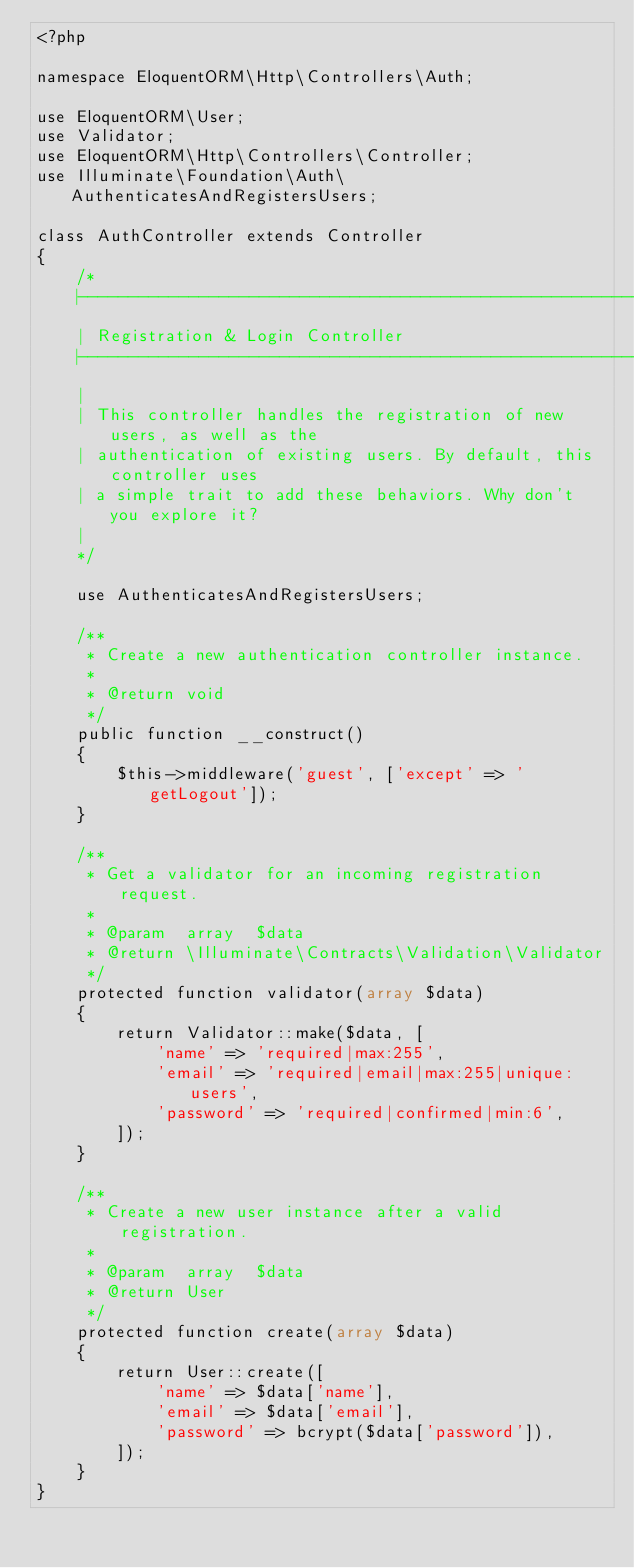<code> <loc_0><loc_0><loc_500><loc_500><_PHP_><?php

namespace EloquentORM\Http\Controllers\Auth;

use EloquentORM\User;
use Validator;
use EloquentORM\Http\Controllers\Controller;
use Illuminate\Foundation\Auth\AuthenticatesAndRegistersUsers;

class AuthController extends Controller
{
    /*
    |--------------------------------------------------------------------------
    | Registration & Login Controller
    |--------------------------------------------------------------------------
    |
    | This controller handles the registration of new users, as well as the
    | authentication of existing users. By default, this controller uses
    | a simple trait to add these behaviors. Why don't you explore it?
    |
    */

    use AuthenticatesAndRegistersUsers;

    /**
     * Create a new authentication controller instance.
     *
     * @return void
     */
    public function __construct()
    {
        $this->middleware('guest', ['except' => 'getLogout']);
    }

    /**
     * Get a validator for an incoming registration request.
     *
     * @param  array  $data
     * @return \Illuminate\Contracts\Validation\Validator
     */
    protected function validator(array $data)
    {
        return Validator::make($data, [
            'name' => 'required|max:255',
            'email' => 'required|email|max:255|unique:users',
            'password' => 'required|confirmed|min:6',
        ]);
    }

    /**
     * Create a new user instance after a valid registration.
     *
     * @param  array  $data
     * @return User
     */
    protected function create(array $data)
    {
        return User::create([
            'name' => $data['name'],
            'email' => $data['email'],
            'password' => bcrypt($data['password']),
        ]);
    }
}
</code> 